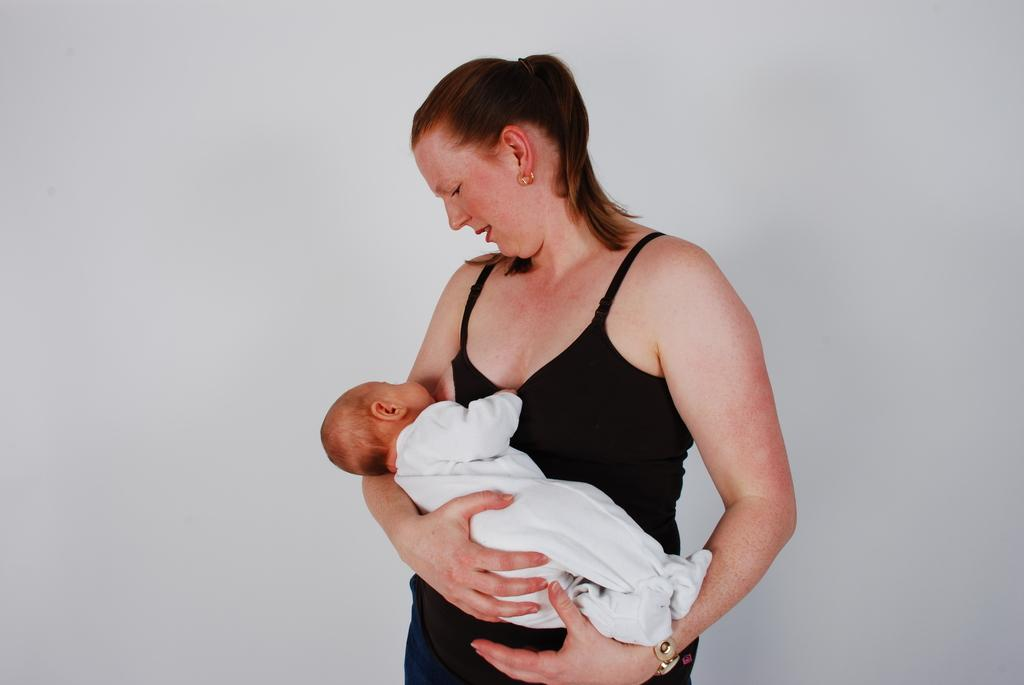Who is the main subject in the image? There is a woman in the image. What is the woman doing in the image? The woman is carrying a baby and looking at the baby. What can be seen in the background of the image? There is a wall in the background of the image. What type of umbrella is the woman holding over the bears in the image? There is no umbrella or bears present in the image. How does the woman create a wave with the baby in the image? The image does not show the woman creating a wave with the baby. 